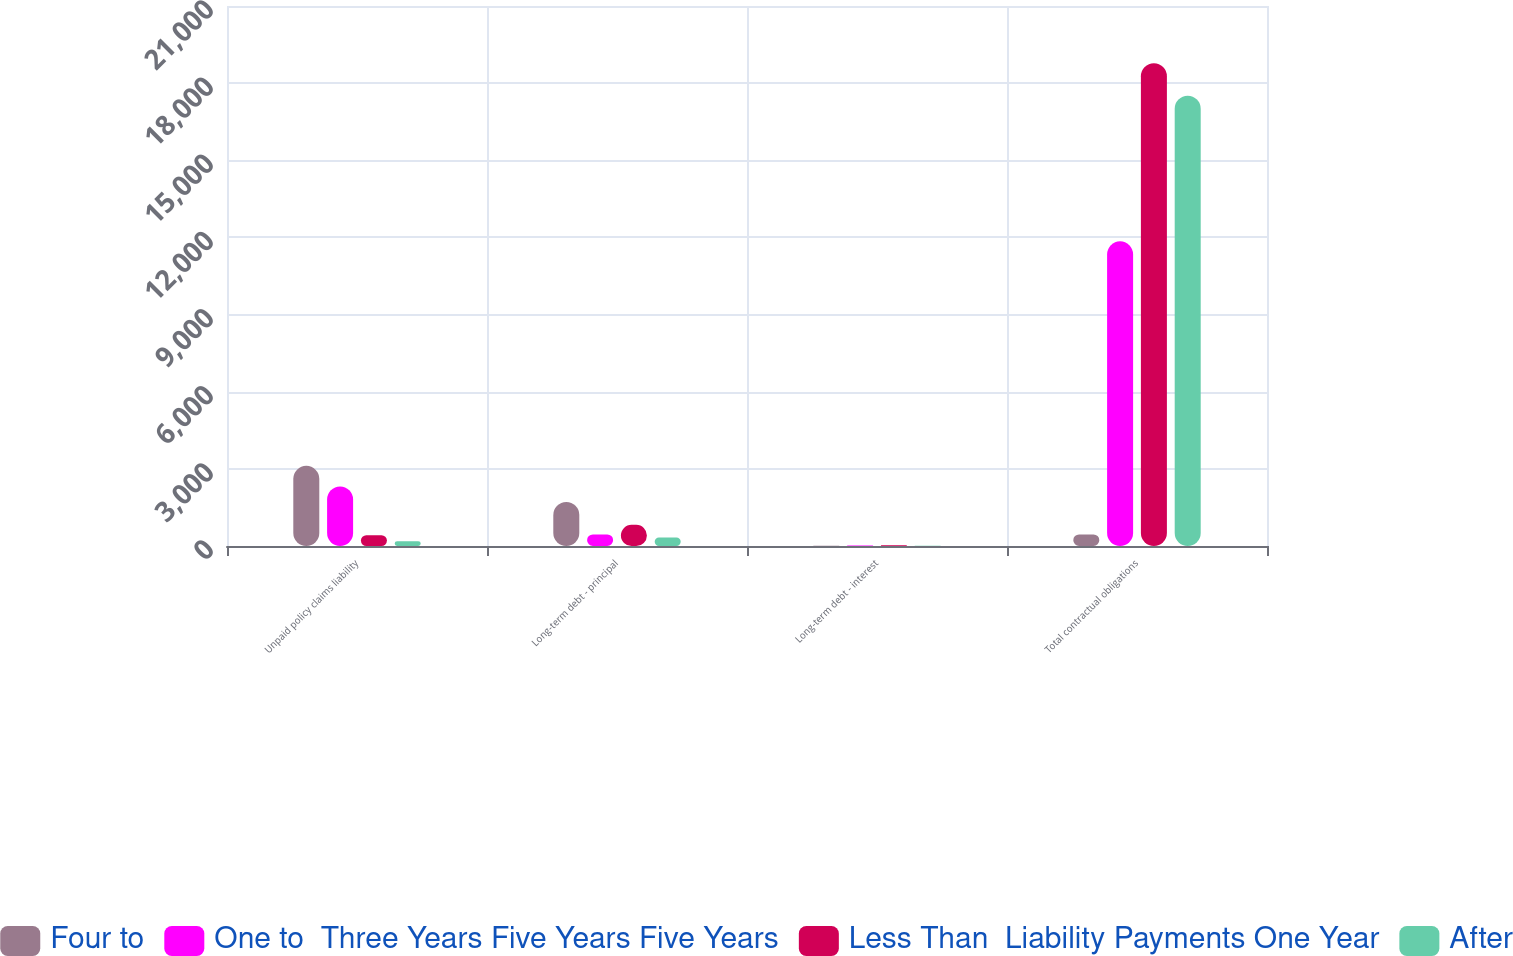Convert chart. <chart><loc_0><loc_0><loc_500><loc_500><stacked_bar_chart><ecel><fcel>Unpaid policy claims liability<fcel>Long-term debt - principal<fcel>Long-term debt - interest<fcel>Total contractual obligations<nl><fcel>Four to<fcel>3118<fcel>1713<fcel>6<fcel>450<nl><fcel>One to  Three Years Five Years Five Years<fcel>2318<fcel>450<fcel>21<fcel>11847<nl><fcel>Less Than  Liability Payments One Year<fcel>422<fcel>824<fcel>29<fcel>18777<nl><fcel>After<fcel>188<fcel>329<fcel>7<fcel>17508<nl></chart> 